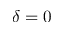Convert formula to latex. <formula><loc_0><loc_0><loc_500><loc_500>\delta = 0</formula> 